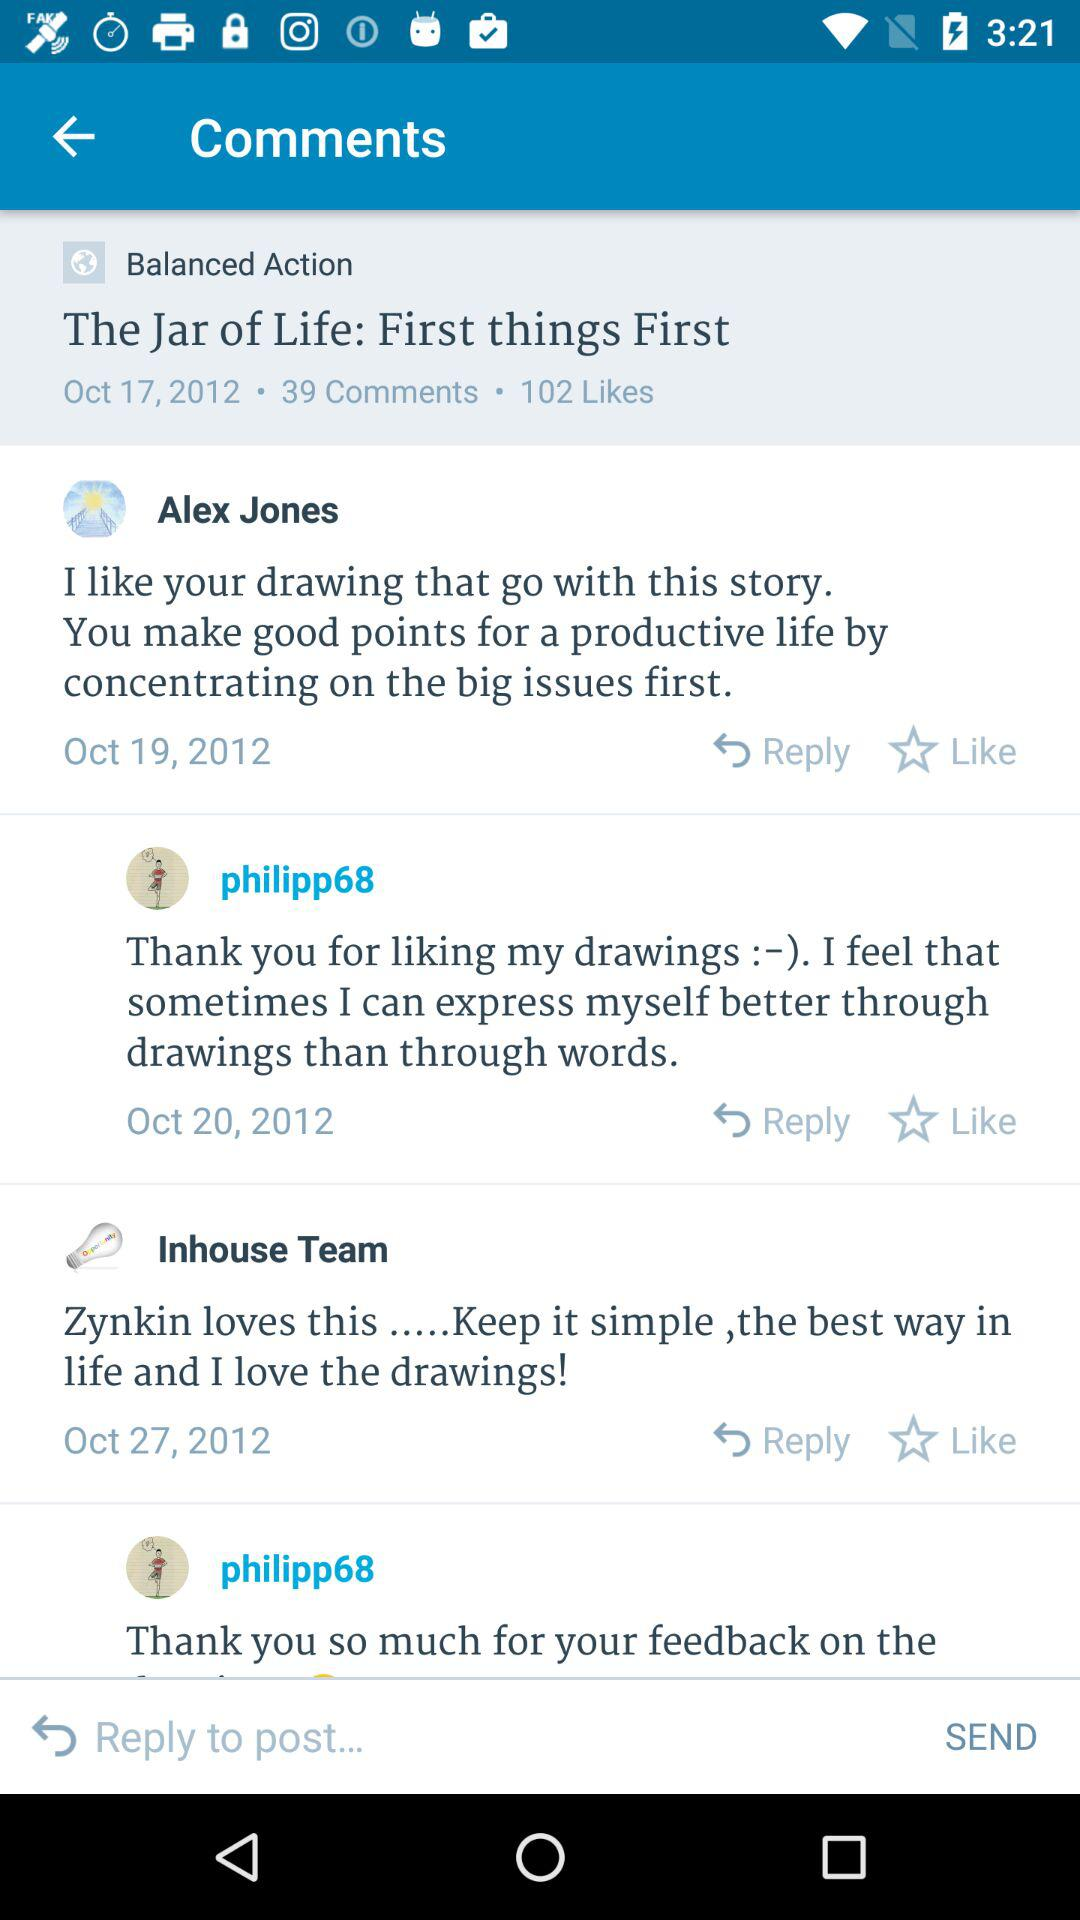Which user's post received 39 comments? The user's post that received 39 comments is "Balanced Action". 